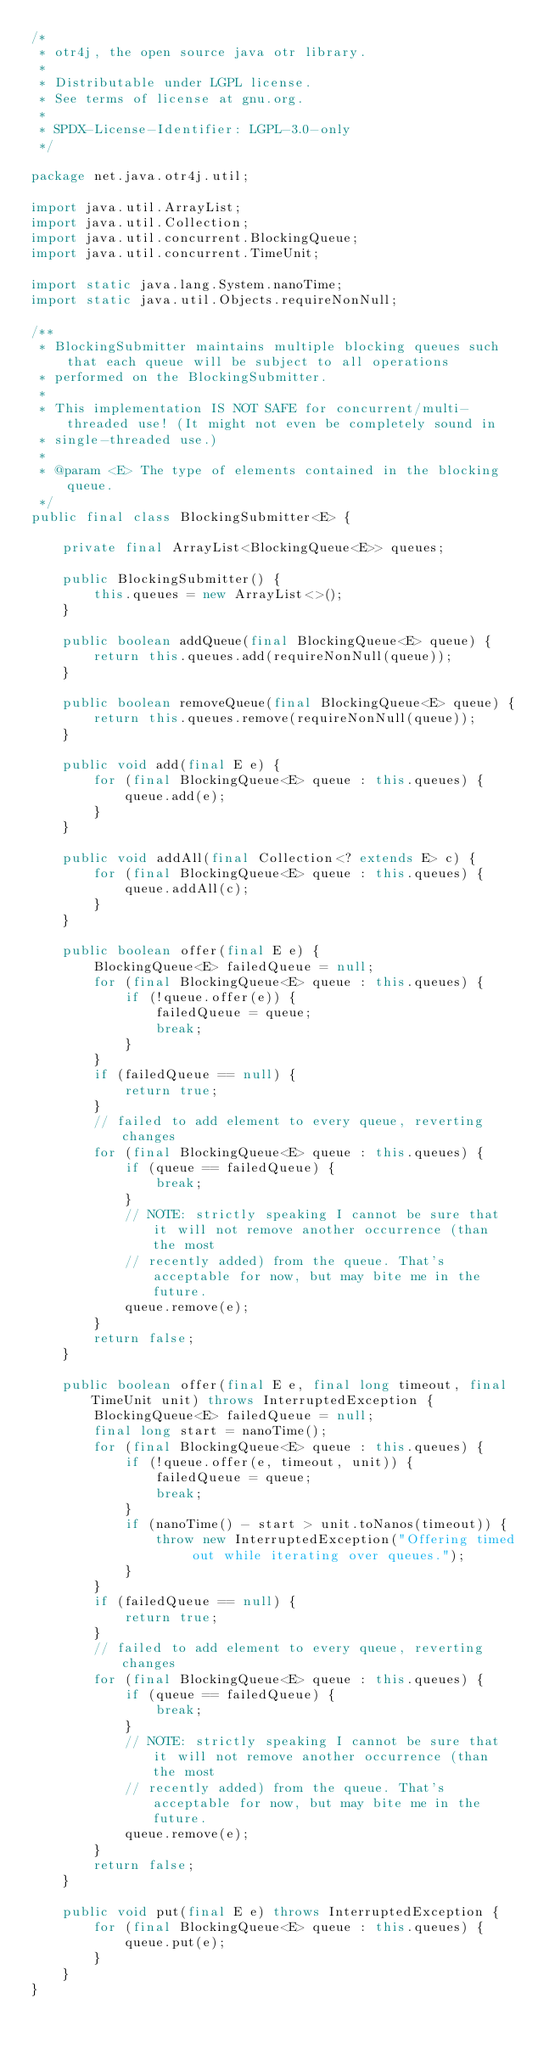<code> <loc_0><loc_0><loc_500><loc_500><_Java_>/*
 * otr4j, the open source java otr library.
 *
 * Distributable under LGPL license.
 * See terms of license at gnu.org.
 *
 * SPDX-License-Identifier: LGPL-3.0-only
 */

package net.java.otr4j.util;

import java.util.ArrayList;
import java.util.Collection;
import java.util.concurrent.BlockingQueue;
import java.util.concurrent.TimeUnit;

import static java.lang.System.nanoTime;
import static java.util.Objects.requireNonNull;

/**
 * BlockingSubmitter maintains multiple blocking queues such that each queue will be subject to all operations
 * performed on the BlockingSubmitter.
 *
 * This implementation IS NOT SAFE for concurrent/multi-threaded use! (It might not even be completely sound in
 * single-threaded use.)
 *
 * @param <E> The type of elements contained in the blocking queue.
 */
public final class BlockingSubmitter<E> {

    private final ArrayList<BlockingQueue<E>> queues;

    public BlockingSubmitter() {
        this.queues = new ArrayList<>();
    }

    public boolean addQueue(final BlockingQueue<E> queue) {
        return this.queues.add(requireNonNull(queue));
    }

    public boolean removeQueue(final BlockingQueue<E> queue) {
        return this.queues.remove(requireNonNull(queue));
    }

    public void add(final E e) {
        for (final BlockingQueue<E> queue : this.queues) {
            queue.add(e);
        }
    }

    public void addAll(final Collection<? extends E> c) {
        for (final BlockingQueue<E> queue : this.queues) {
            queue.addAll(c);
        }
    }

    public boolean offer(final E e) {
        BlockingQueue<E> failedQueue = null;
        for (final BlockingQueue<E> queue : this.queues) {
            if (!queue.offer(e)) {
                failedQueue = queue;
                break;
            }
        }
        if (failedQueue == null) {
            return true;
        }
        // failed to add element to every queue, reverting changes
        for (final BlockingQueue<E> queue : this.queues) {
            if (queue == failedQueue) {
                break;
            }
            // NOTE: strictly speaking I cannot be sure that it will not remove another occurrence (than the most
            // recently added) from the queue. That's acceptable for now, but may bite me in the future.
            queue.remove(e);
        }
        return false;
    }

    public boolean offer(final E e, final long timeout, final TimeUnit unit) throws InterruptedException {
        BlockingQueue<E> failedQueue = null;
        final long start = nanoTime();
        for (final BlockingQueue<E> queue : this.queues) {
            if (!queue.offer(e, timeout, unit)) {
                failedQueue = queue;
                break;
            }
            if (nanoTime() - start > unit.toNanos(timeout)) {
                throw new InterruptedException("Offering timed out while iterating over queues.");
            }
        }
        if (failedQueue == null) {
            return true;
        }
        // failed to add element to every queue, reverting changes
        for (final BlockingQueue<E> queue : this.queues) {
            if (queue == failedQueue) {
                break;
            }
            // NOTE: strictly speaking I cannot be sure that it will not remove another occurrence (than the most
            // recently added) from the queue. That's acceptable for now, but may bite me in the future.
            queue.remove(e);
        }
        return false;
    }

    public void put(final E e) throws InterruptedException {
        for (final BlockingQueue<E> queue : this.queues) {
            queue.put(e);
        }
    }
}
</code> 